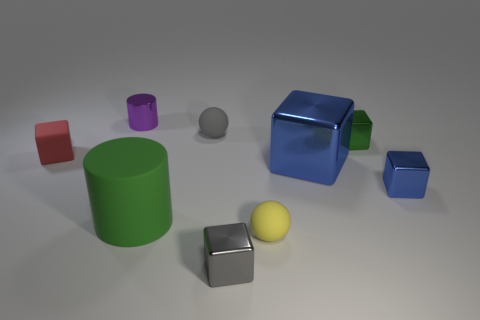Is the number of large blue shiny cubes that are behind the small purple cylinder greater than the number of tiny green objects?
Provide a succinct answer. No. How many other things are there of the same size as the red thing?
Your response must be concise. 6. Is the tiny cylinder the same color as the matte cylinder?
Provide a short and direct response. No. What color is the matte object that is to the left of the green object that is in front of the small shiny cube that is behind the tiny matte block?
Ensure brevity in your answer.  Red. There is a tiny red cube that is left of the metal object on the left side of the large green matte thing; what number of tiny matte blocks are on the right side of it?
Give a very brief answer. 0. Is there anything else that is the same color as the big metal object?
Provide a short and direct response. Yes. There is a shiny thing that is in front of the green matte cylinder; is it the same size as the big green object?
Provide a succinct answer. No. How many tiny purple cylinders are left of the thing to the left of the tiny shiny cylinder?
Make the answer very short. 0. Are there any small matte things that are in front of the cube that is to the left of the cylinder that is in front of the gray rubber thing?
Provide a short and direct response. Yes. What material is the purple thing that is the same shape as the green rubber object?
Provide a succinct answer. Metal. 